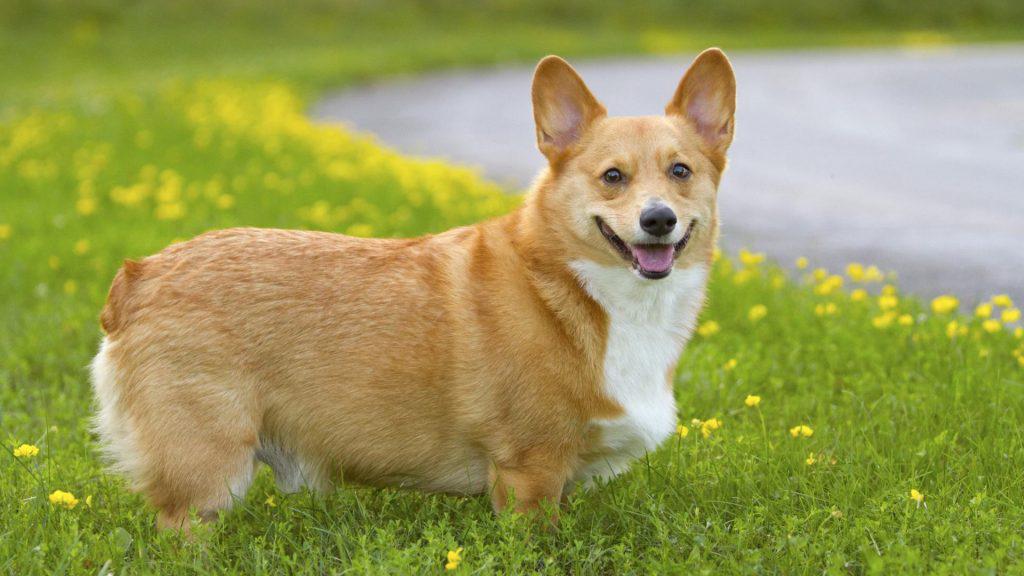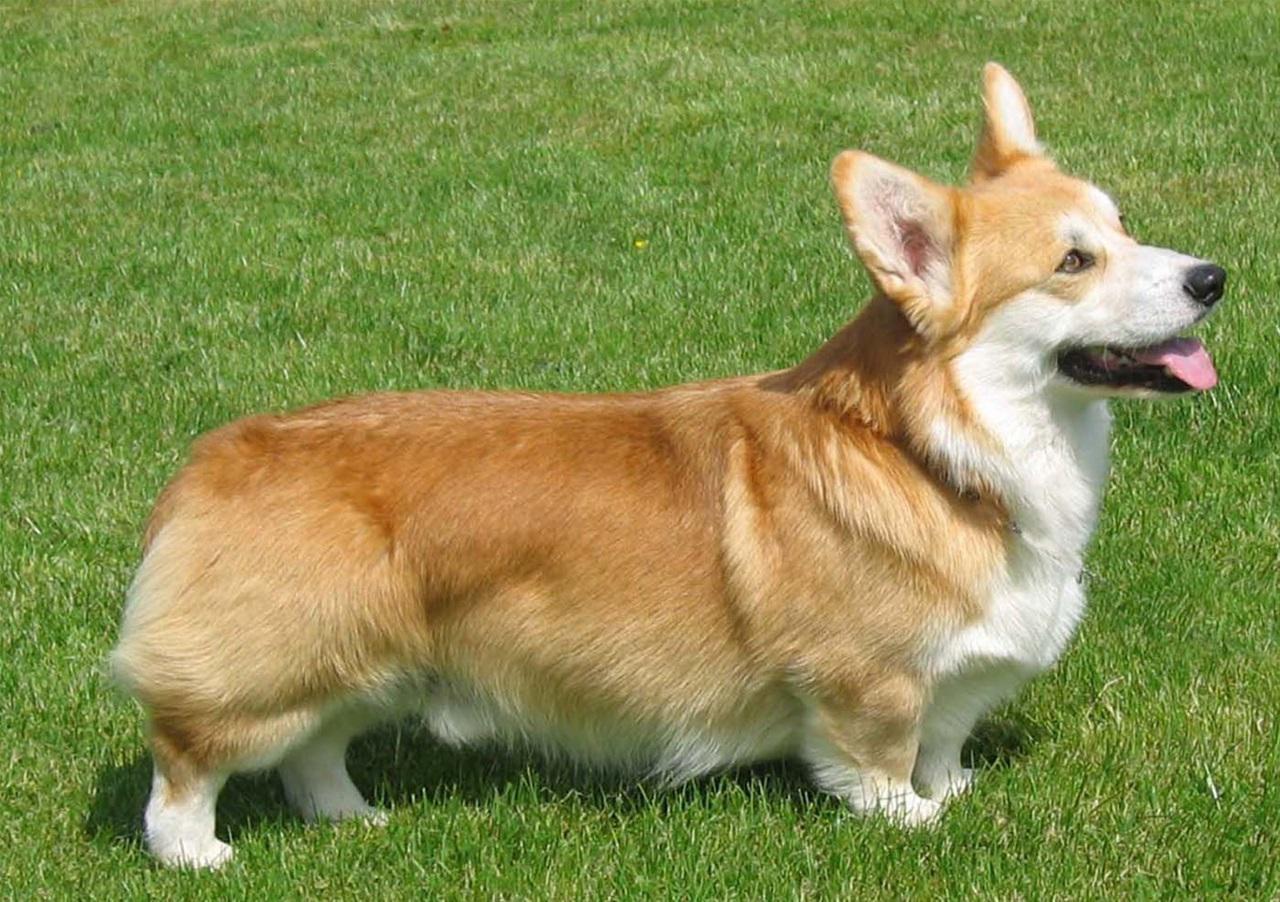The first image is the image on the left, the second image is the image on the right. For the images displayed, is the sentence "Exactly one dog is pointed to the right." factually correct? Answer yes or no. No. The first image is the image on the left, the second image is the image on the right. For the images displayed, is the sentence "there is at least one dog with dog tags in the image pair" factually correct? Answer yes or no. No. 